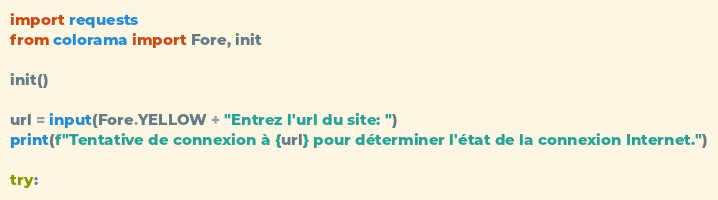Convert code to text. <code><loc_0><loc_0><loc_500><loc_500><_Python_>import requests
from colorama import Fore, init

init()

url = input(Fore.YELLOW + "Entrez l'url du site: ")
print(f"Tentative de connexion à {url} pour déterminer l'état de la connexion Internet.")

try:</code> 